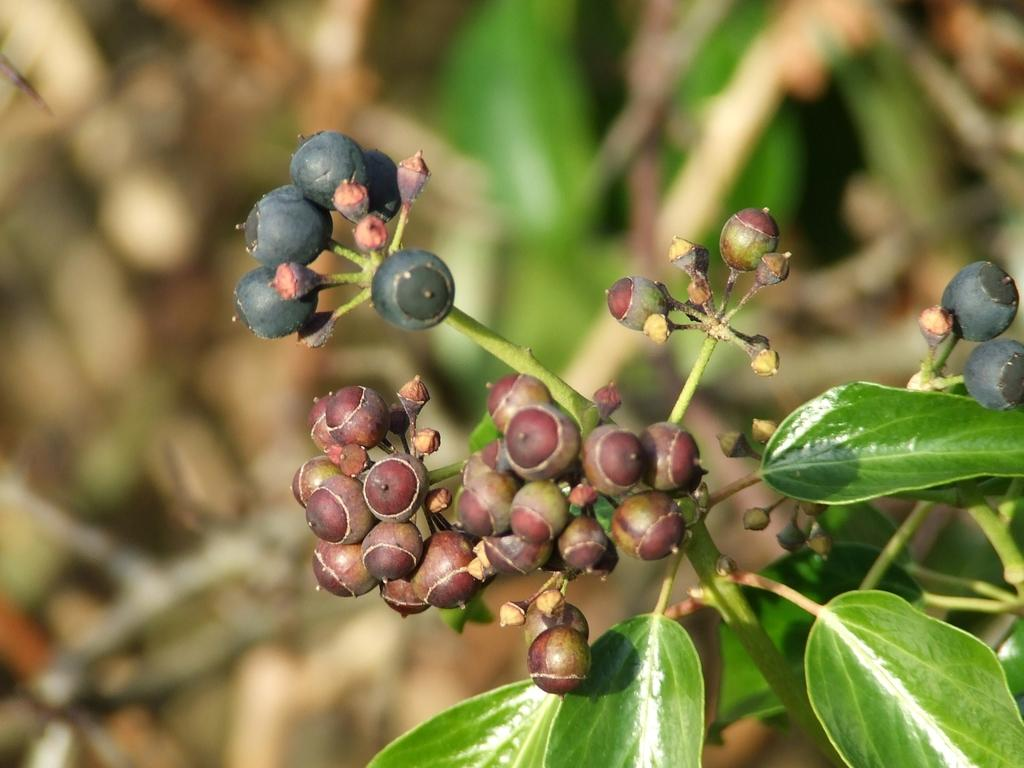What is located in the center of the image? There are fruits and leaves in the center of the image. Can you describe the fruits and leaves in the image? Unfortunately, the provided facts do not give any information about the specific type of fruits or leaves. What can be observed about the background of the image? The background of the image is blurry. How far away is your mom from the fruits in the image? There is no information about your mom or any distance in the image. The image only shows fruits and leaves in the center, with a blurry background. 